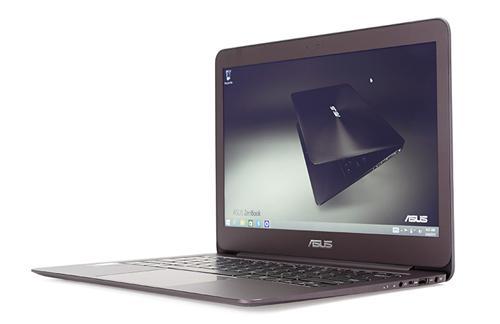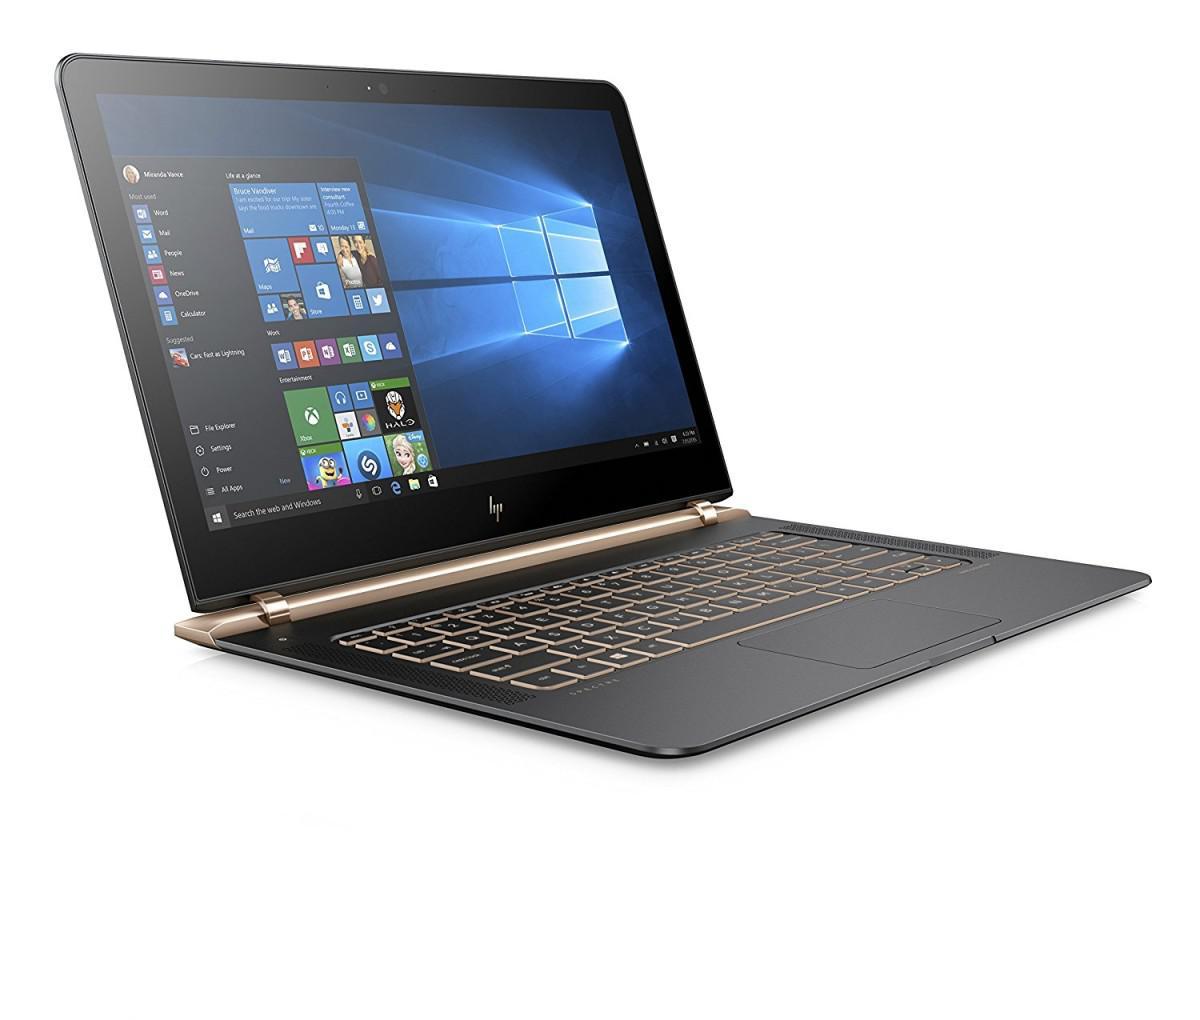The first image is the image on the left, the second image is the image on the right. Considering the images on both sides, is "Each image shows a single open laptop, and each laptop is open to an angle of at least 90 degrees." valid? Answer yes or no. Yes. 